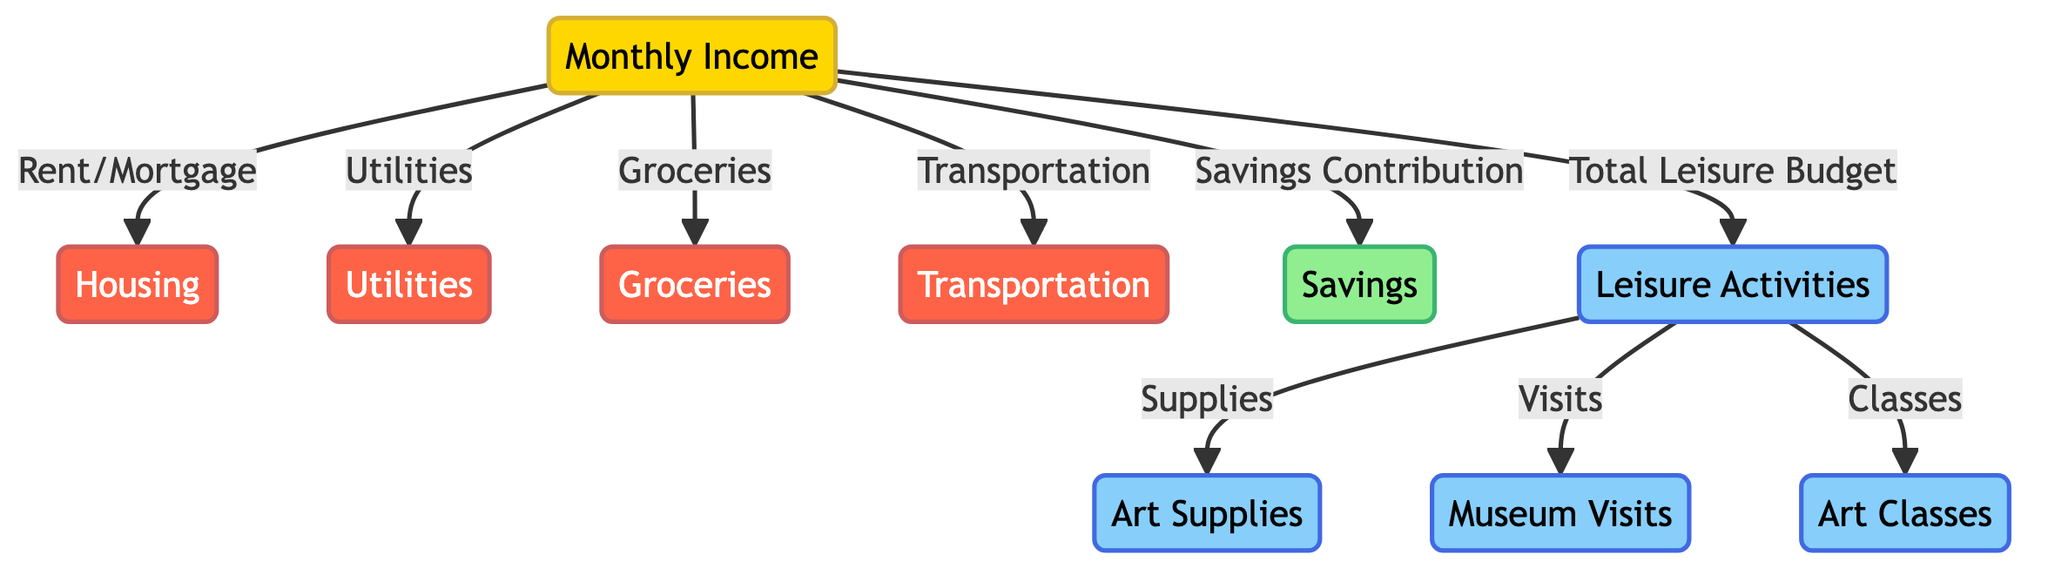What is the total monthly income derived from this diagram? The diagram presents "Monthly Income" as the main entry point. Since it is the single source of flow for expenses and leisure activities, it indicates that there is one total monthly income amount. This value is not specified in the diagram but represents the entirety of the individual's income.
Answer: Monthly Income How many types of leisure activities are included in the budget? The leisure category consists of three distinct types of activities: Art Supplies, Museum Visits, and Art Classes. These can be counted directly from the leisure section, revealing how many specific leisure activities are allocated within the budget.
Answer: Three What is the relationship between monthly income and savings? "Monthly Income" directly flows into the "Savings Contribution" node, indicating that a portion of the monthly income is allocated towards savings. The diagram’s structure shows a direct connection between the two, suggesting a flow of funds.
Answer: Direct connection Which expense category is directly related to "Transport"? "Transportation" is explicitly listed as one of the categories under expenses, which indicates where part of the monthly income is allocated. Tracking the flow from monthly income shows it moves directly to "Transportation."
Answer: Transportation What percentage of the total monthly income is allocated to leisure activities? To ascertain this, one needs to tally the total allocations. The diagram divides portions of income for various categories. Understanding the relationship where "Total Leisure Budget" is a segment of the monthly income allows for calculating the percentage based on actual values, although figures are not provided in the diagram.
Answer: Not specified in the diagram Which expense category is *not* linked to "Monthly Income"? The diagram indicates that all expenses stem from "Monthly Income." However, since "Savings" functions separately as a contribution and not a direct expense, it can be differentiated from the expense categories tied closely to monthly income allocation.
Answer: None What part of the diagram categorizes "Art Supplies"? "Art Supplies" falls under the "Leisure Activities" section as a related subsection reflecting a particular allocation towards leisure-focused spending. This can be seen as it branches off from the leisure node.
Answer: Leisure Activities How are art classes funded in this budget? Art classes are funded directly from the "Leisure Budget," which is allocated a portion of the "Monthly Income." This relationship of income leading to leisure activities showcases the funding source for art classes.
Answer: Through Leisure Budget 